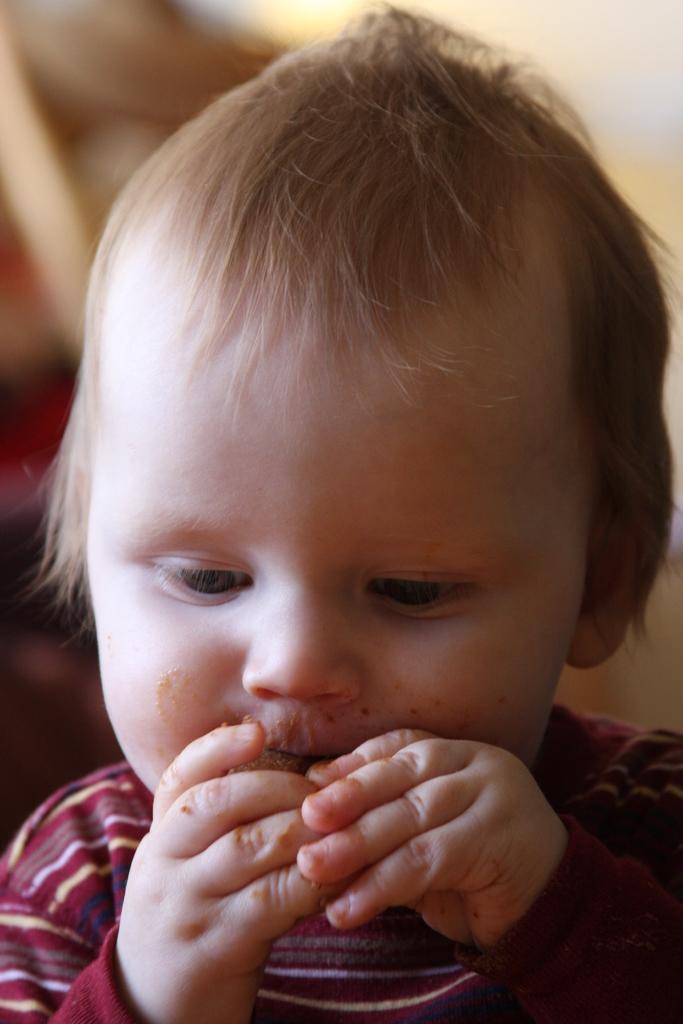Please provide a concise description of this image. In this picture we can see a child holding food and in the background it is blurry. 